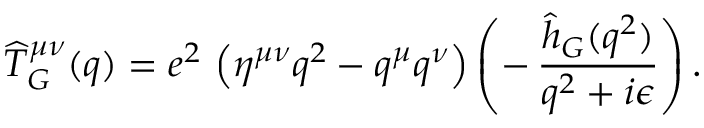<formula> <loc_0><loc_0><loc_500><loc_500>{ \widehat { T } _ { G } } ^ { \mu \nu } ( q ) = e ^ { 2 } \, \left ( \eta ^ { \mu \nu } q ^ { 2 } - q ^ { \mu } q ^ { \nu } \right ) \left ( - \, { \frac { \hat { h } _ { G } ( q ^ { 2 } ) } { q ^ { 2 } + i \epsilon } } \right ) .</formula> 